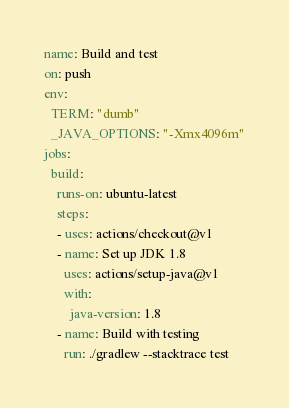<code> <loc_0><loc_0><loc_500><loc_500><_YAML_>name: Build and test
on: push
env:
  TERM: "dumb"
  _JAVA_OPTIONS: "-Xmx4096m"
jobs:
  build:
    runs-on: ubuntu-latest
    steps:
    - uses: actions/checkout@v1
    - name: Set up JDK 1.8
      uses: actions/setup-java@v1
      with:
        java-version: 1.8
    - name: Build with testing
      run: ./gradlew --stacktrace test
</code> 